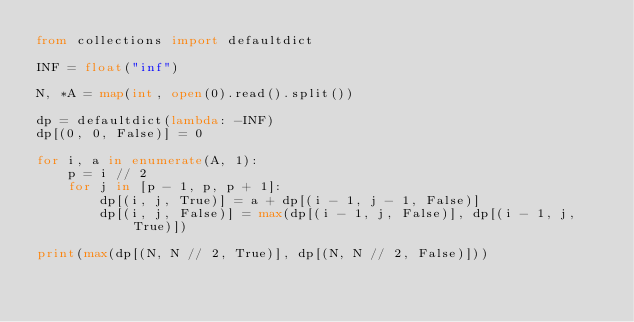<code> <loc_0><loc_0><loc_500><loc_500><_Python_>from collections import defaultdict

INF = float("inf")

N, *A = map(int, open(0).read().split())

dp = defaultdict(lambda: -INF)
dp[(0, 0, False)] = 0

for i, a in enumerate(A, 1):
    p = i // 2
    for j in [p - 1, p, p + 1]:
        dp[(i, j, True)] = a + dp[(i - 1, j - 1, False)]
        dp[(i, j, False)] = max(dp[(i - 1, j, False)], dp[(i - 1, j, True)])

print(max(dp[(N, N // 2, True)], dp[(N, N // 2, False)]))</code> 